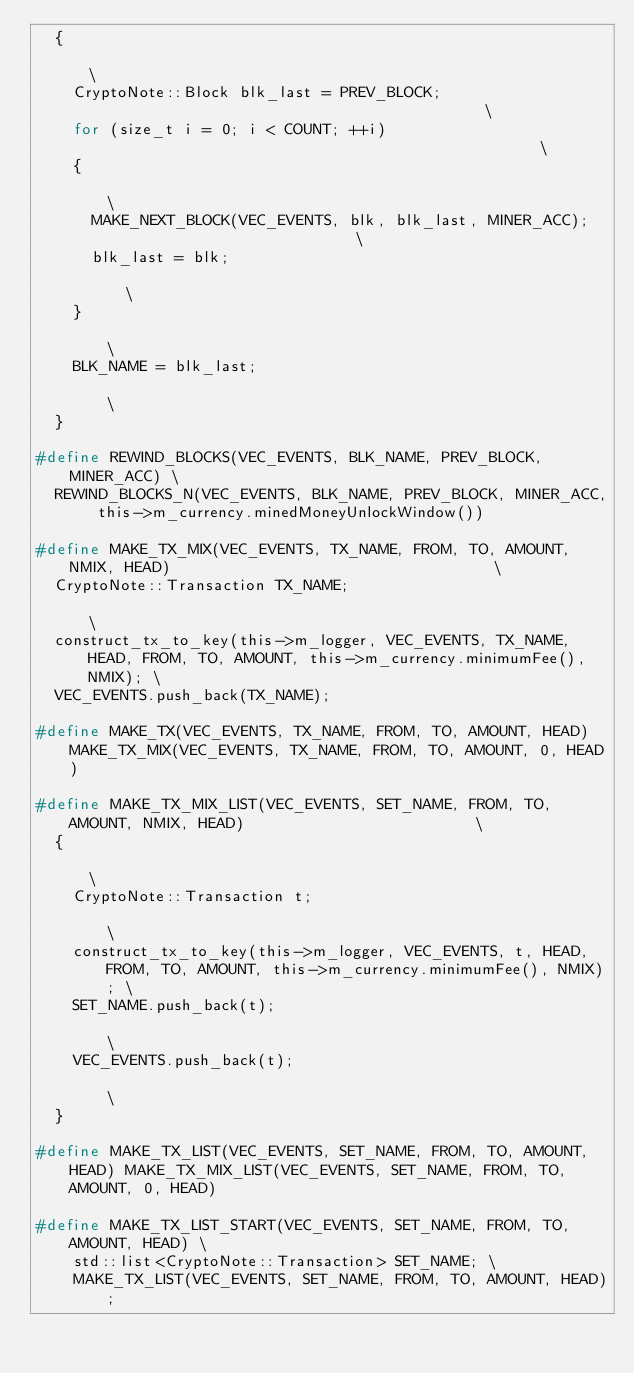<code> <loc_0><loc_0><loc_500><loc_500><_C_>  {                                                                                   \
    CryptoNote::Block blk_last = PREV_BLOCK;                                          \
    for (size_t i = 0; i < COUNT; ++i)                                                \
    {                                                                                 \
      MAKE_NEXT_BLOCK(VEC_EVENTS, blk, blk_last, MINER_ACC);                          \
      blk_last = blk;                                                                 \
    }                                                                                 \
    BLK_NAME = blk_last;                                                              \
  }

#define REWIND_BLOCKS(VEC_EVENTS, BLK_NAME, PREV_BLOCK, MINER_ACC) \
  REWIND_BLOCKS_N(VEC_EVENTS, BLK_NAME, PREV_BLOCK, MINER_ACC, this->m_currency.minedMoneyUnlockWindow())

#define MAKE_TX_MIX(VEC_EVENTS, TX_NAME, FROM, TO, AMOUNT, NMIX, HEAD)                                   \
  CryptoNote::Transaction TX_NAME;                                                                       \
  construct_tx_to_key(this->m_logger, VEC_EVENTS, TX_NAME, HEAD, FROM, TO, AMOUNT, this->m_currency.minimumFee(), NMIX); \
  VEC_EVENTS.push_back(TX_NAME);

#define MAKE_TX(VEC_EVENTS, TX_NAME, FROM, TO, AMOUNT, HEAD) MAKE_TX_MIX(VEC_EVENTS, TX_NAME, FROM, TO, AMOUNT, 0, HEAD)

#define MAKE_TX_MIX_LIST(VEC_EVENTS, SET_NAME, FROM, TO, AMOUNT, NMIX, HEAD)                         \
  {                                                                                                  \
    CryptoNote::Transaction t;                                                                       \
    construct_tx_to_key(this->m_logger, VEC_EVENTS, t, HEAD, FROM, TO, AMOUNT, this->m_currency.minimumFee(), NMIX); \
    SET_NAME.push_back(t);                                                                           \
    VEC_EVENTS.push_back(t);                                                                         \
  }

#define MAKE_TX_LIST(VEC_EVENTS, SET_NAME, FROM, TO, AMOUNT, HEAD) MAKE_TX_MIX_LIST(VEC_EVENTS, SET_NAME, FROM, TO, AMOUNT, 0, HEAD)

#define MAKE_TX_LIST_START(VEC_EVENTS, SET_NAME, FROM, TO, AMOUNT, HEAD) \
    std::list<CryptoNote::Transaction> SET_NAME; \
    MAKE_TX_LIST(VEC_EVENTS, SET_NAME, FROM, TO, AMOUNT, HEAD);
</code> 